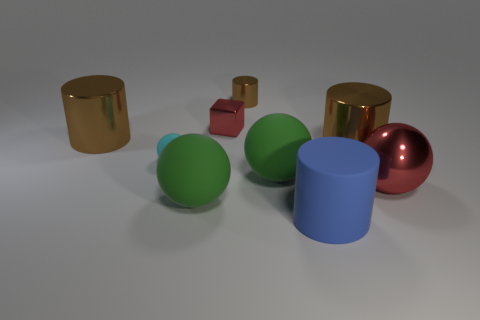How many brown cylinders must be subtracted to get 1 brown cylinders? 2 Subtract all cyan balls. How many brown cylinders are left? 3 Subtract 1 cylinders. How many cylinders are left? 3 Add 1 big green matte cylinders. How many objects exist? 10 Subtract all cubes. How many objects are left? 8 Subtract all big brown cylinders. Subtract all matte spheres. How many objects are left? 4 Add 8 big green objects. How many big green objects are left? 10 Add 4 spheres. How many spheres exist? 8 Subtract 2 brown cylinders. How many objects are left? 7 